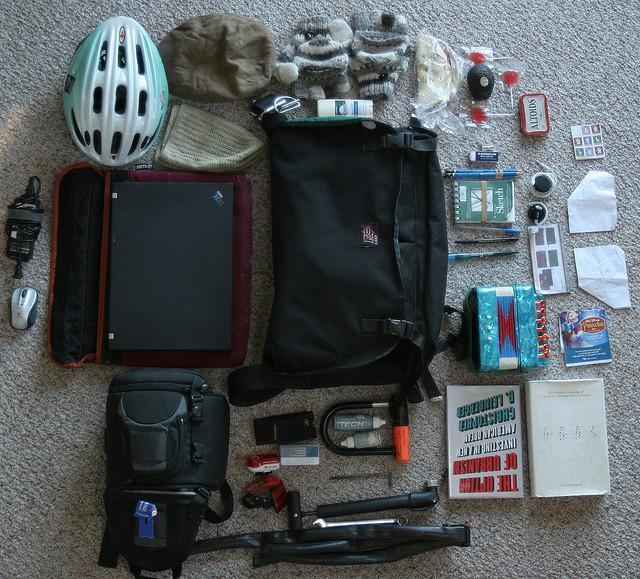How many books are visible?
Give a very brief answer. 2. 